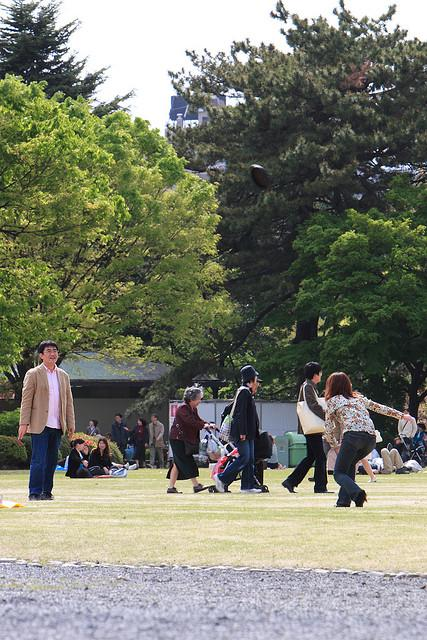What is the likely relation of the person pushing the stroller to the child in it? grandma 